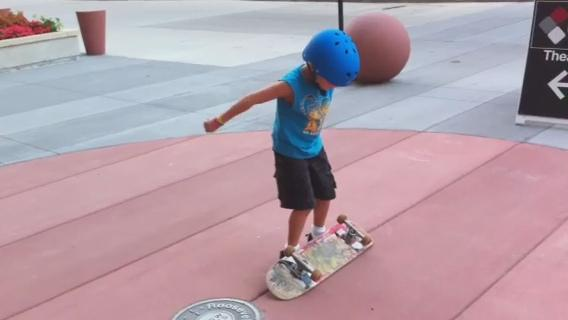What will the child try to do first? flip skateboard 